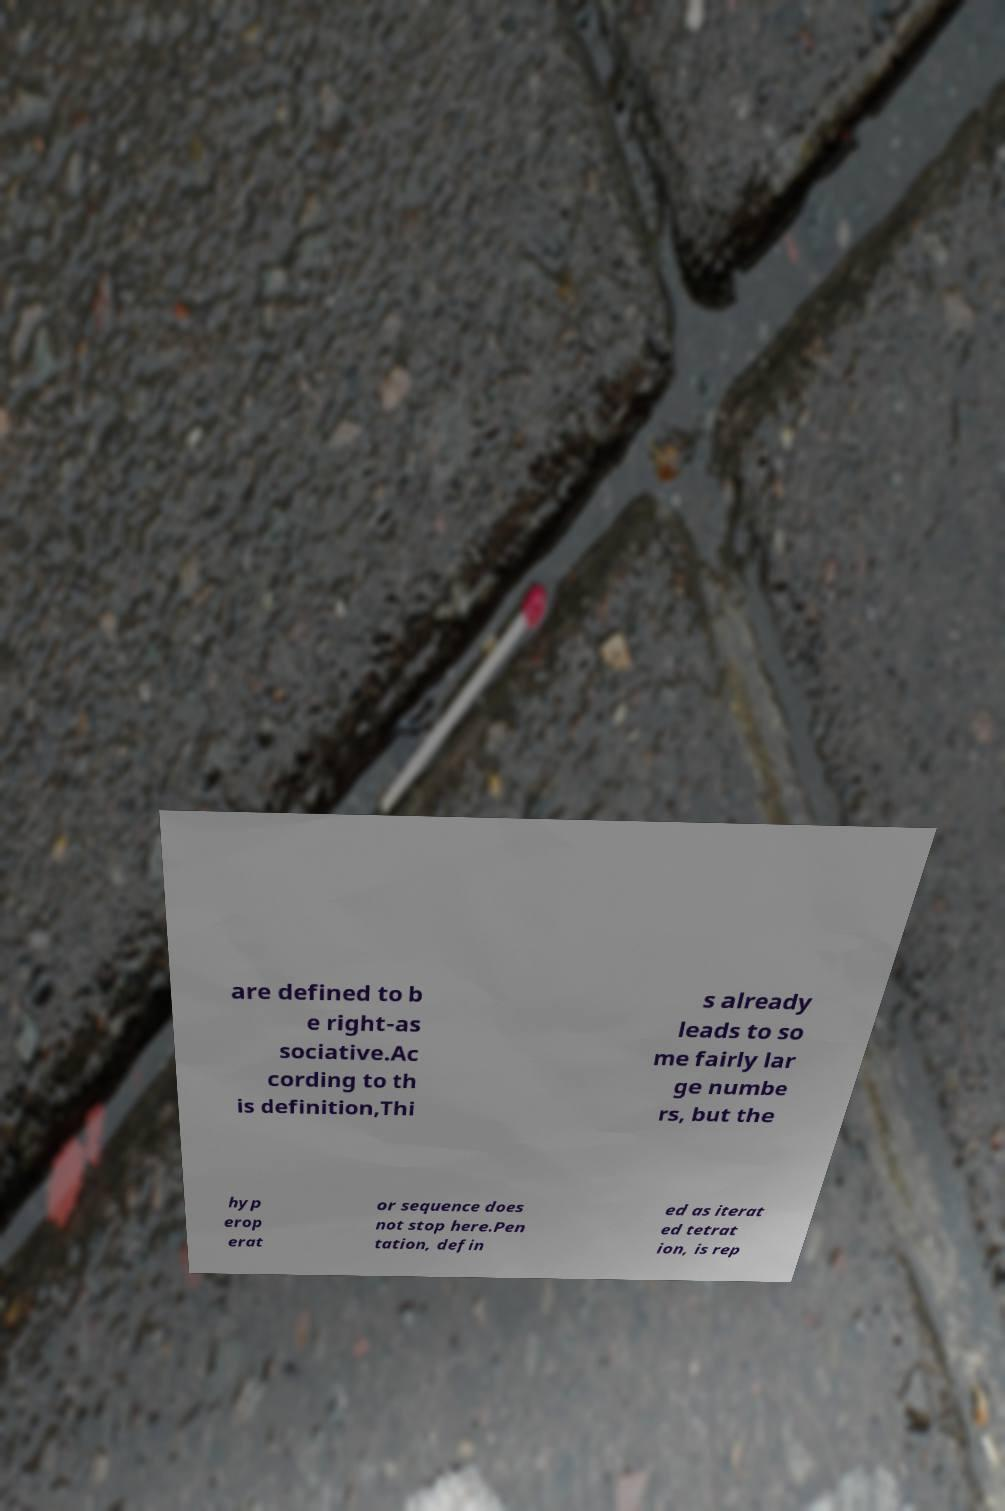There's text embedded in this image that I need extracted. Can you transcribe it verbatim? are defined to b e right-as sociative.Ac cording to th is definition,Thi s already leads to so me fairly lar ge numbe rs, but the hyp erop erat or sequence does not stop here.Pen tation, defin ed as iterat ed tetrat ion, is rep 